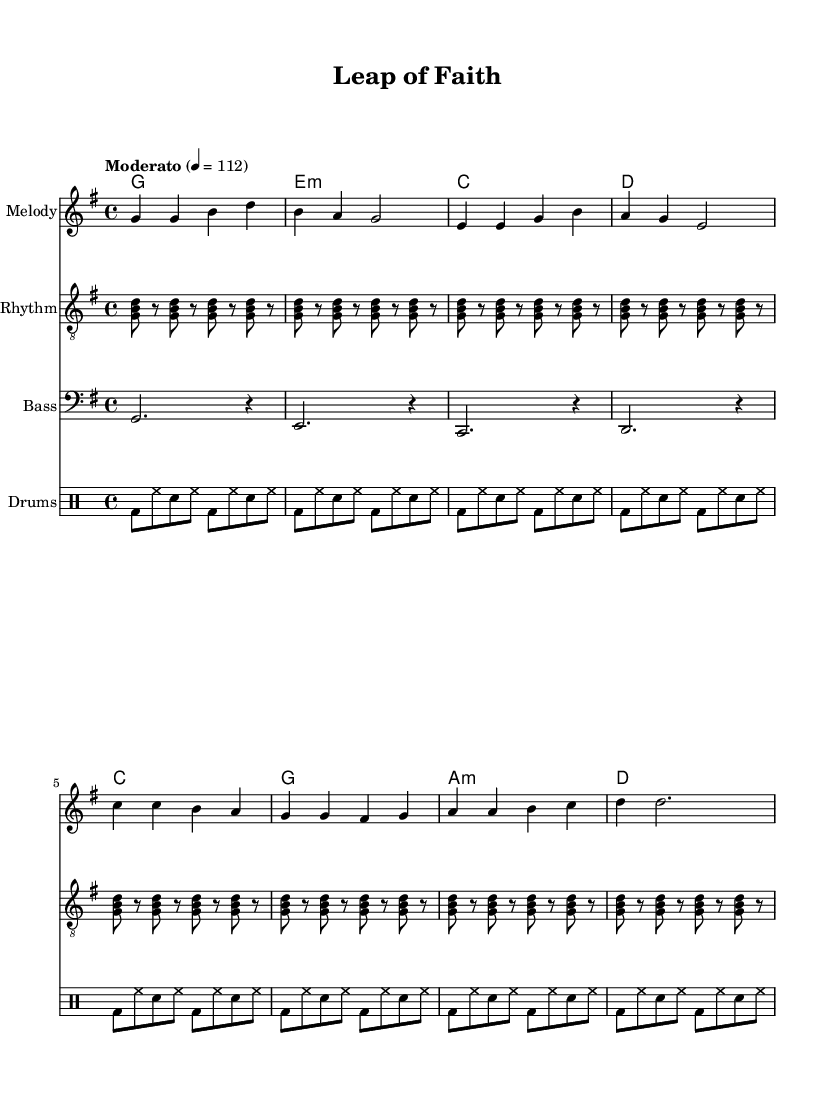What is the key signature of this music? The key signature indicates a G major scale, which has one sharp (F#). This is apparent from the key signature indicated at the beginning of the score.
Answer: G major What is the time signature of this music? The time signature is 4/4, as shown at the beginning of the piece next to the key signature. This means there are four beats in each measure and a quarter note receives one beat.
Answer: 4/4 What is the tempo marking for this piece? The tempo marking at the beginning shows "Moderato" with a metronome marking of 112. This indicates that the music should be played at a moderate speed of 112 beats per minute.
Answer: Moderato, 112 How many measures are there in the chorus? By counting the total number of measures that contain the lyrics associated with the chorus section in the score, we find there are four measures. Each measure is represented in both the melody and the chord changes.
Answer: 4 What is the primary theme expressed in the lyrics of this song? The lyrics of the verse express uncertainty but with a hopeful view, while the chorus emphasizes taking risks and creating one's fate, which are central themes in contemporary folk-rock.
Answer: Innovation and risk-taking What instruments are featured in this arrangement? The score includes four different parts: a melody, rhythm guitar, bass guitar, and drums. Each is notated in separate staves within the score, allowing for a full arrangement.
Answer: Melody, Rhythm Guitar, Bass Guitar, Drums What chords are used in the verse progression? The chords in the verse are G, E minor, C, and D, which can be identified in the chord section corresponding to the melody. These are standard chords commonly used in folk-rock music.
Answer: G, E minor, C, D 